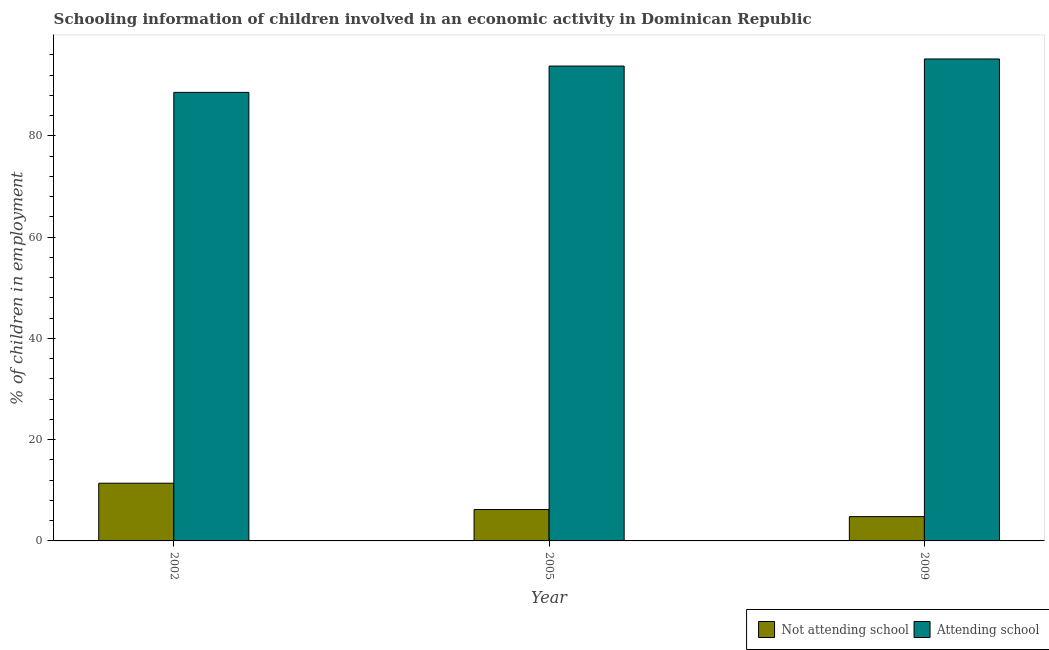Are the number of bars per tick equal to the number of legend labels?
Ensure brevity in your answer.  Yes. Are the number of bars on each tick of the X-axis equal?
Offer a very short reply. Yes. How many bars are there on the 2nd tick from the right?
Offer a very short reply. 2. In how many cases, is the number of bars for a given year not equal to the number of legend labels?
Your answer should be compact. 0. Across all years, what is the maximum percentage of employed children who are attending school?
Your answer should be very brief. 95.2. Across all years, what is the minimum percentage of employed children who are not attending school?
Give a very brief answer. 4.8. In which year was the percentage of employed children who are not attending school maximum?
Keep it short and to the point. 2002. In which year was the percentage of employed children who are attending school minimum?
Ensure brevity in your answer.  2002. What is the total percentage of employed children who are not attending school in the graph?
Offer a very short reply. 22.4. What is the difference between the percentage of employed children who are attending school in 2002 and that in 2009?
Your answer should be compact. -6.6. What is the difference between the percentage of employed children who are not attending school in 2009 and the percentage of employed children who are attending school in 2005?
Your answer should be very brief. -1.4. What is the average percentage of employed children who are attending school per year?
Offer a terse response. 92.53. In how many years, is the percentage of employed children who are not attending school greater than 44 %?
Give a very brief answer. 0. What is the ratio of the percentage of employed children who are attending school in 2002 to that in 2009?
Your answer should be very brief. 0.93. Is the difference between the percentage of employed children who are not attending school in 2005 and 2009 greater than the difference between the percentage of employed children who are attending school in 2005 and 2009?
Your answer should be very brief. No. What is the difference between the highest and the lowest percentage of employed children who are not attending school?
Your answer should be compact. 6.6. In how many years, is the percentage of employed children who are not attending school greater than the average percentage of employed children who are not attending school taken over all years?
Give a very brief answer. 1. Is the sum of the percentage of employed children who are attending school in 2002 and 2005 greater than the maximum percentage of employed children who are not attending school across all years?
Keep it short and to the point. Yes. What does the 1st bar from the left in 2002 represents?
Your answer should be compact. Not attending school. What does the 1st bar from the right in 2009 represents?
Your answer should be compact. Attending school. How many bars are there?
Offer a very short reply. 6. Where does the legend appear in the graph?
Offer a terse response. Bottom right. What is the title of the graph?
Your response must be concise. Schooling information of children involved in an economic activity in Dominican Republic. What is the label or title of the Y-axis?
Provide a short and direct response. % of children in employment. What is the % of children in employment in Not attending school in 2002?
Give a very brief answer. 11.4. What is the % of children in employment in Attending school in 2002?
Provide a short and direct response. 88.6. What is the % of children in employment in Attending school in 2005?
Give a very brief answer. 93.8. What is the % of children in employment in Attending school in 2009?
Make the answer very short. 95.2. Across all years, what is the maximum % of children in employment of Attending school?
Provide a short and direct response. 95.2. Across all years, what is the minimum % of children in employment of Attending school?
Offer a terse response. 88.6. What is the total % of children in employment in Not attending school in the graph?
Offer a very short reply. 22.4. What is the total % of children in employment of Attending school in the graph?
Your answer should be very brief. 277.6. What is the difference between the % of children in employment of Not attending school in 2005 and that in 2009?
Provide a short and direct response. 1.4. What is the difference between the % of children in employment of Attending school in 2005 and that in 2009?
Offer a terse response. -1.4. What is the difference between the % of children in employment in Not attending school in 2002 and the % of children in employment in Attending school in 2005?
Provide a succinct answer. -82.4. What is the difference between the % of children in employment in Not attending school in 2002 and the % of children in employment in Attending school in 2009?
Offer a terse response. -83.8. What is the difference between the % of children in employment of Not attending school in 2005 and the % of children in employment of Attending school in 2009?
Provide a short and direct response. -89. What is the average % of children in employment in Not attending school per year?
Provide a short and direct response. 7.47. What is the average % of children in employment in Attending school per year?
Your response must be concise. 92.53. In the year 2002, what is the difference between the % of children in employment of Not attending school and % of children in employment of Attending school?
Offer a very short reply. -77.2. In the year 2005, what is the difference between the % of children in employment of Not attending school and % of children in employment of Attending school?
Your response must be concise. -87.6. In the year 2009, what is the difference between the % of children in employment in Not attending school and % of children in employment in Attending school?
Your response must be concise. -90.4. What is the ratio of the % of children in employment in Not attending school in 2002 to that in 2005?
Keep it short and to the point. 1.84. What is the ratio of the % of children in employment in Attending school in 2002 to that in 2005?
Offer a terse response. 0.94. What is the ratio of the % of children in employment of Not attending school in 2002 to that in 2009?
Your answer should be very brief. 2.38. What is the ratio of the % of children in employment of Attending school in 2002 to that in 2009?
Offer a very short reply. 0.93. What is the ratio of the % of children in employment of Not attending school in 2005 to that in 2009?
Your answer should be compact. 1.29. What is the ratio of the % of children in employment in Attending school in 2005 to that in 2009?
Provide a short and direct response. 0.99. What is the difference between the highest and the lowest % of children in employment of Not attending school?
Provide a short and direct response. 6.6. What is the difference between the highest and the lowest % of children in employment of Attending school?
Your response must be concise. 6.6. 